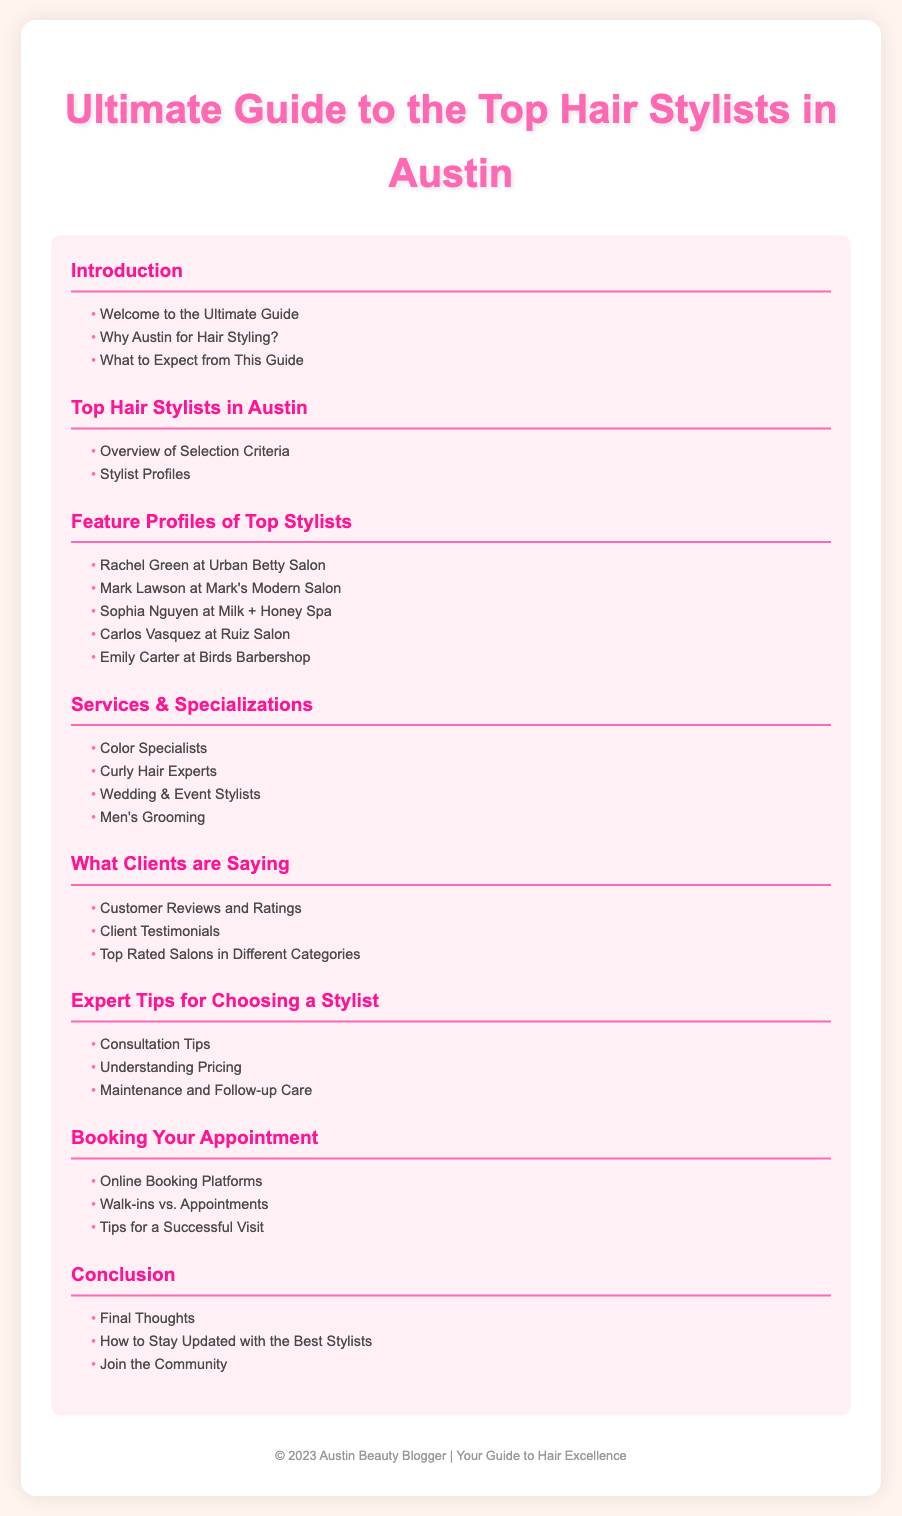what is the title of the document? The title is prominently displayed at the top of the document.
Answer: Ultimate Guide to the Top Hair Stylists in Austin how many sections are in the table of contents? The number of sections can be counted from the displayed TOC.
Answer: 7 who is featured at Urban Betty Salon? The document lists the stylists associated with specific salons.
Answer: Rachel Green what kinds of services are highlighted under Services & Specializations? This can be found by reviewing the subsection titles under the relevant section.
Answer: Color Specialists, Curly Hair Experts, Wedding & Event Stylists, Men's Grooming what tips are included in the Expert Tips for Choosing a Stylist section? By reading the subsections, we can identify what tips are provided.
Answer: Consultation Tips, Understanding Pricing, Maintenance and Follow-up Care what section comes after Booking Your Appointment? The order of the sections provides this information directly.
Answer: Conclusion how can clients stay updated with the best stylists according to the conclusion? The conclusion section offers recommendations on staying updated.
Answer: How to Stay Updated with the Best Stylists 